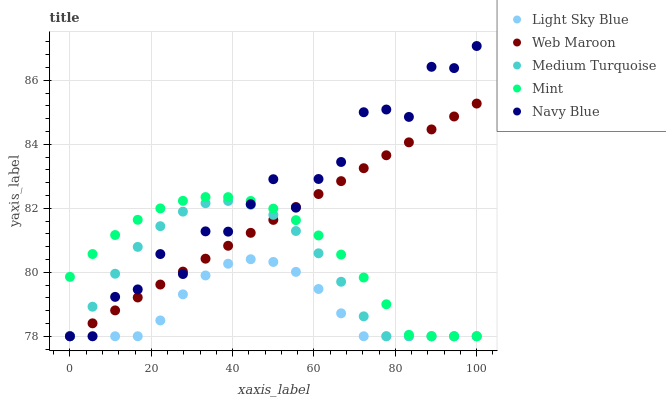Does Light Sky Blue have the minimum area under the curve?
Answer yes or no. Yes. Does Navy Blue have the maximum area under the curve?
Answer yes or no. Yes. Does Web Maroon have the minimum area under the curve?
Answer yes or no. No. Does Web Maroon have the maximum area under the curve?
Answer yes or no. No. Is Web Maroon the smoothest?
Answer yes or no. Yes. Is Navy Blue the roughest?
Answer yes or no. Yes. Is Light Sky Blue the smoothest?
Answer yes or no. No. Is Light Sky Blue the roughest?
Answer yes or no. No. Does Mint have the lowest value?
Answer yes or no. Yes. Does Navy Blue have the highest value?
Answer yes or no. Yes. Does Web Maroon have the highest value?
Answer yes or no. No. Does Web Maroon intersect Navy Blue?
Answer yes or no. Yes. Is Web Maroon less than Navy Blue?
Answer yes or no. No. Is Web Maroon greater than Navy Blue?
Answer yes or no. No. 